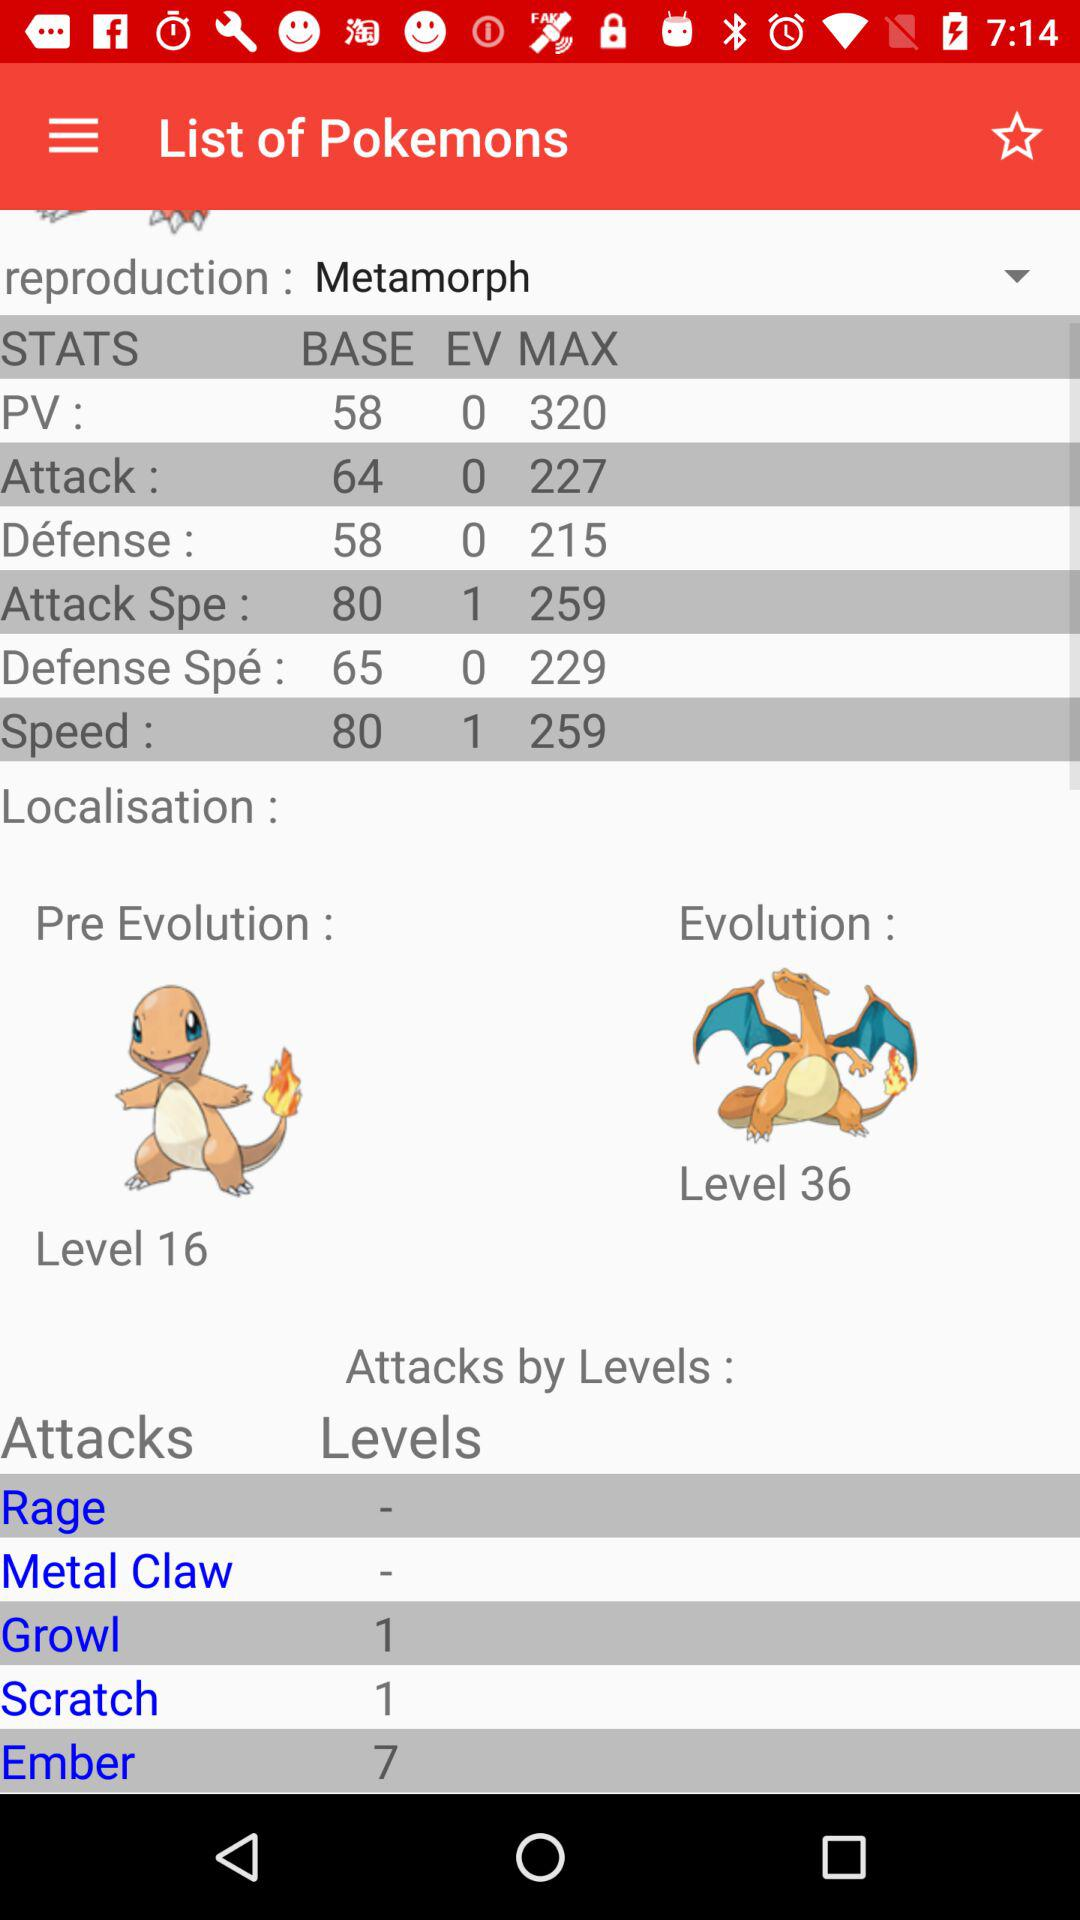Which option is selected for reproduction? The selected option is "Metamorph". 